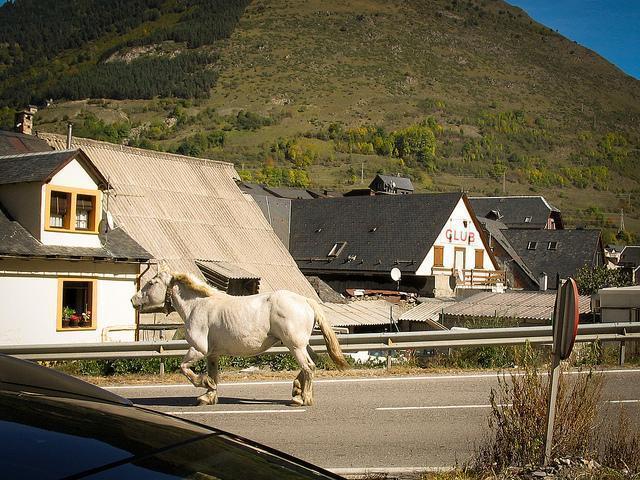Why are the roofs at street level?
Indicate the correct response by choosing from the four available options to answer the question.
Options: Street missing, houses sank, broken camera, street below. Street below. 